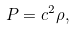Convert formula to latex. <formula><loc_0><loc_0><loc_500><loc_500>P = c ^ { 2 } \rho ,</formula> 